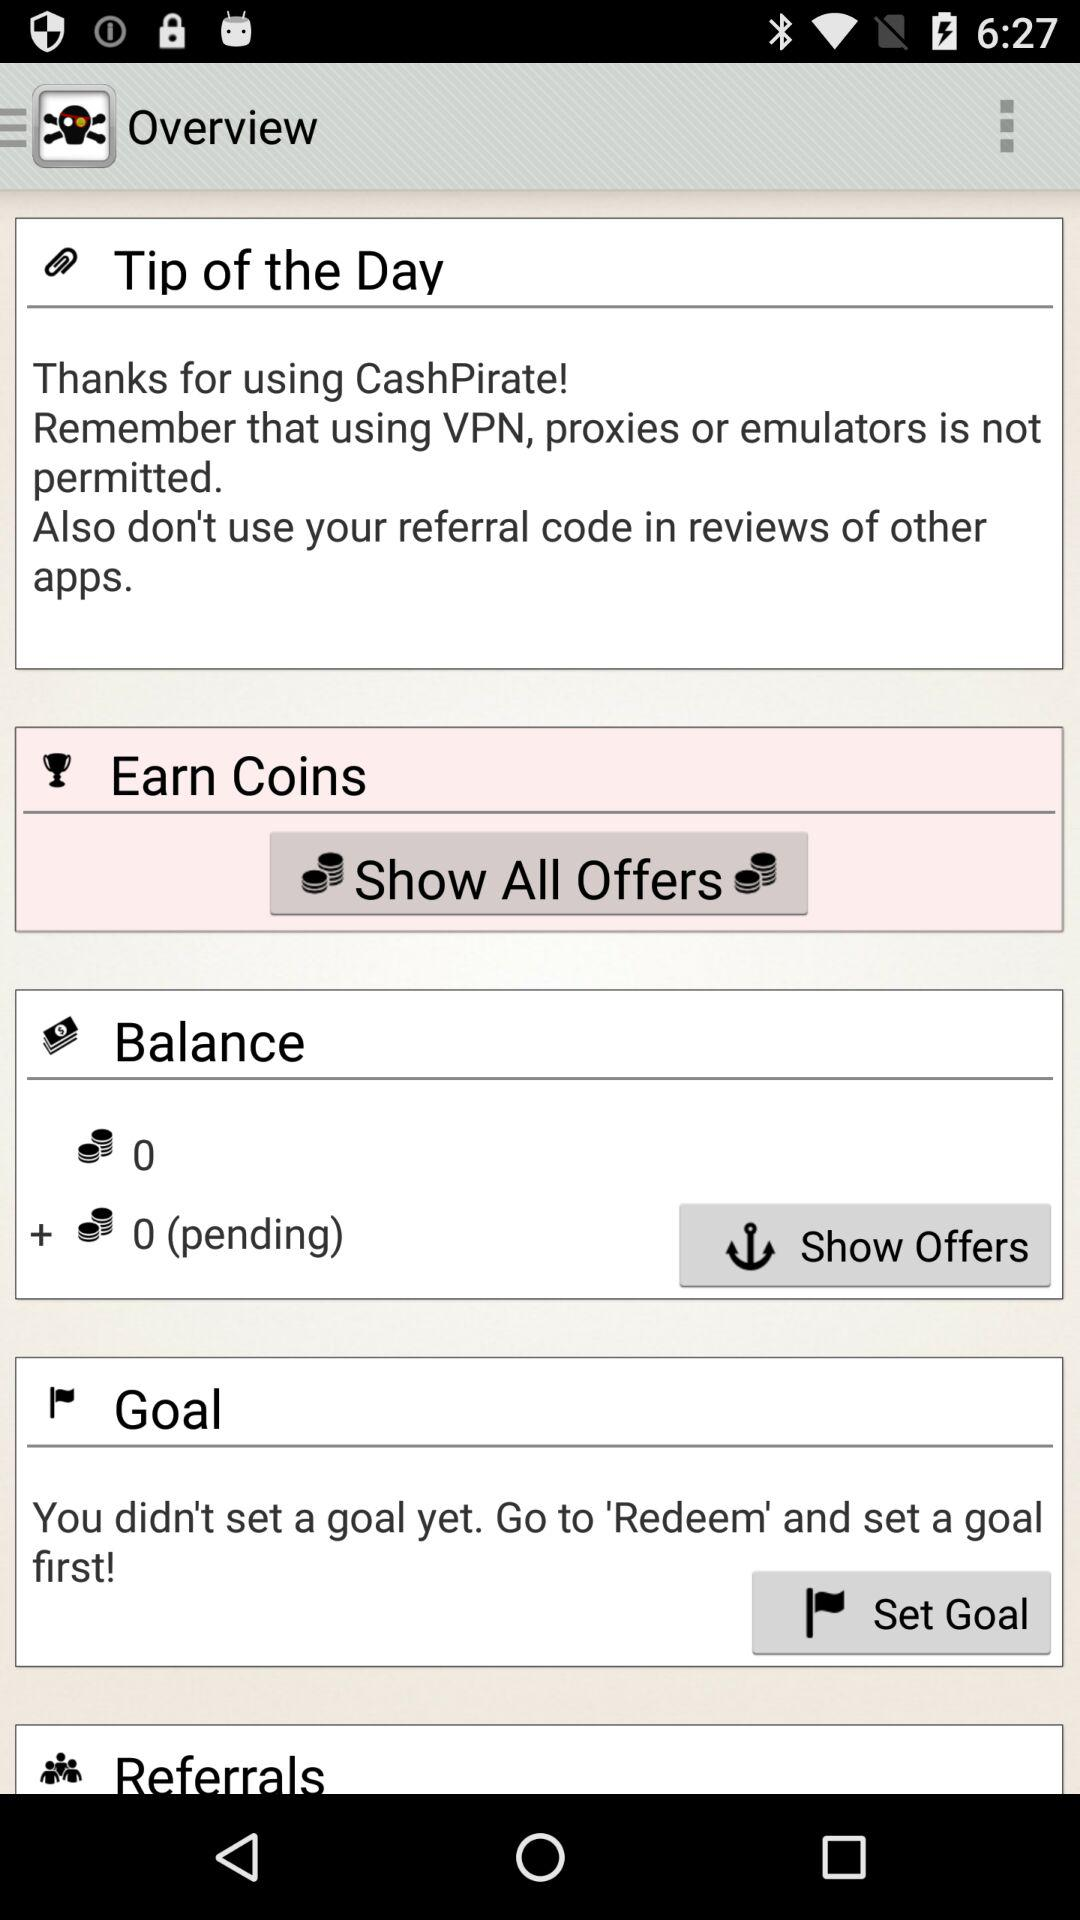How many more pending coins are there than earned coins?
Answer the question using a single word or phrase. 0 